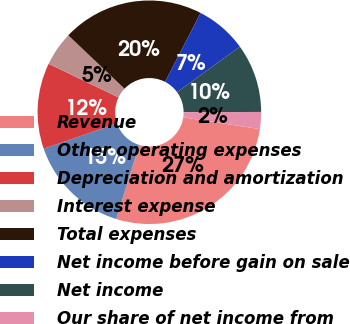Convert chart to OTSL. <chart><loc_0><loc_0><loc_500><loc_500><pie_chart><fcel>Revenue<fcel>Other operating expenses<fcel>Depreciation and amortization<fcel>Interest expense<fcel>Total expenses<fcel>Net income before gain on sale<fcel>Net income<fcel>Our share of net income from<nl><fcel>27.39%<fcel>14.92%<fcel>12.43%<fcel>4.94%<fcel>20.5%<fcel>7.44%<fcel>9.93%<fcel>2.45%<nl></chart> 